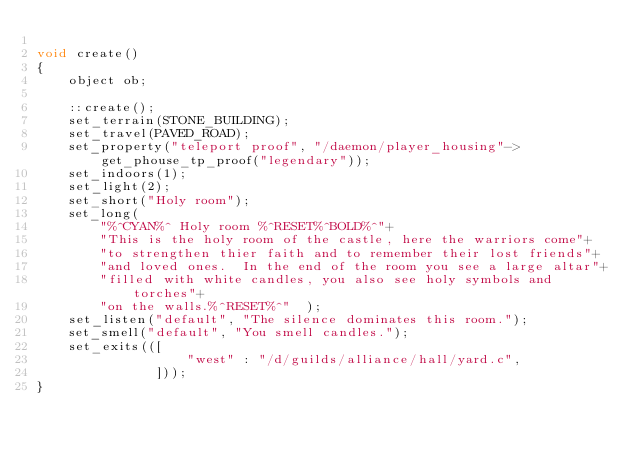<code> <loc_0><loc_0><loc_500><loc_500><_C_>
void create()
{
    object ob;

    ::create();
    set_terrain(STONE_BUILDING);
    set_travel(PAVED_ROAD);
    set_property("teleport proof", "/daemon/player_housing"->get_phouse_tp_proof("legendary"));
    set_indoors(1);
    set_light(2);
    set_short("Holy room");
    set_long(
        "%^CYAN%^ Holy room %^RESET%^BOLD%^"+
        "This is the holy room of the castle, here the warriors come"+
        "to strengthen thier faith and to remember their lost friends"+
        "and loved ones.  In the end of the room you see a large altar"+
        "filled with white candles, you also see holy symbols and torches"+
        "on the walls.%^RESET%^"  );
    set_listen("default", "The silence dominates this room.");
    set_smell("default", "You smell candles.");
    set_exits(([
                   "west" : "/d/guilds/alliance/hall/yard.c",
               ]));
}</code> 